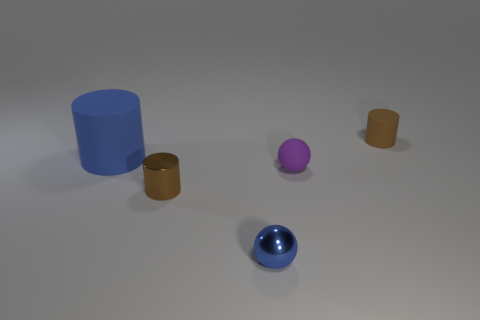Add 3 big red metallic cubes. How many objects exist? 8 Subtract all tiny brown cylinders. How many cylinders are left? 1 Subtract all blue cylinders. How many cylinders are left? 2 Subtract all gray spheres. How many brown cylinders are left? 2 Subtract 3 cylinders. How many cylinders are left? 0 Subtract 0 gray spheres. How many objects are left? 5 Subtract all cylinders. How many objects are left? 2 Subtract all gray cylinders. Subtract all brown spheres. How many cylinders are left? 3 Subtract all brown things. Subtract all small brown rubber things. How many objects are left? 2 Add 4 brown matte cylinders. How many brown matte cylinders are left? 5 